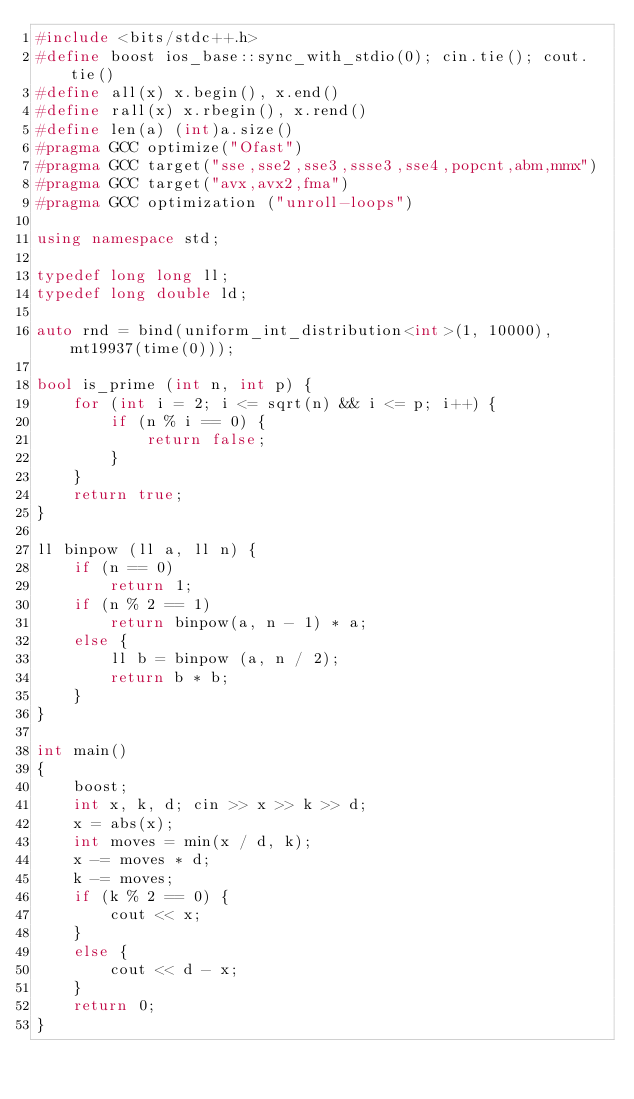<code> <loc_0><loc_0><loc_500><loc_500><_C++_>#include <bits/stdc++.h>
#define boost ios_base::sync_with_stdio(0); cin.tie(); cout.tie()
#define all(x) x.begin(), x.end()
#define rall(x) x.rbegin(), x.rend()
#define len(a) (int)a.size()
#pragma GCC optimize("Ofast")
#pragma GCC target("sse,sse2,sse3,ssse3,sse4,popcnt,abm,mmx")
#pragma GCC target("avx,avx2,fma")
#pragma GCC optimization ("unroll-loops")

using namespace std;

typedef long long ll;
typedef long double ld;

auto rnd = bind(uniform_int_distribution<int>(1, 10000), mt19937(time(0)));

bool is_prime (int n, int p) {
    for (int i = 2; i <= sqrt(n) && i <= p; i++) {
        if (n % i == 0) {
            return false;
        }
    }
    return true;
}

ll binpow (ll a, ll n) {
	if (n == 0)
		return 1;
	if (n % 2 == 1)
		return binpow(a, n - 1) * a;
	else {
		ll b = binpow (a, n / 2);
		return b * b;
	}
}

int main()
{
    boost;
    int x, k, d; cin >> x >> k >> d;
    x = abs(x);
    int moves = min(x / d, k);
    x -= moves * d;
    k -= moves;
    if (k % 2 == 0) {
        cout << x;
    }
    else {
        cout << d - x;
    }
    return 0;
}

</code> 